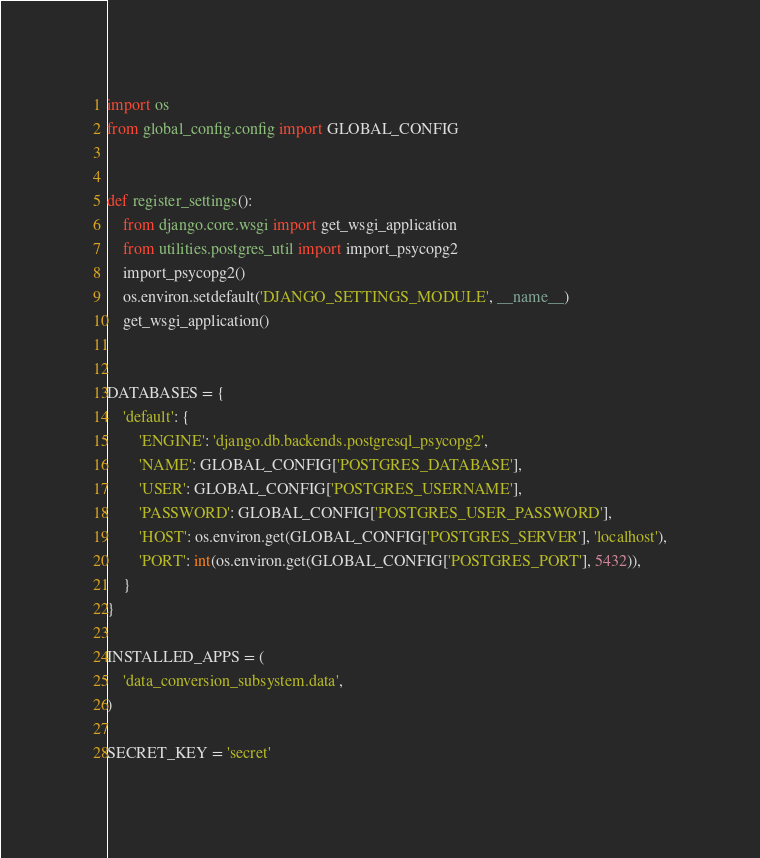<code> <loc_0><loc_0><loc_500><loc_500><_Python_>import os
from global_config.config import GLOBAL_CONFIG


def register_settings():
    from django.core.wsgi import get_wsgi_application
    from utilities.postgres_util import import_psycopg2
    import_psycopg2()
    os.environ.setdefault('DJANGO_SETTINGS_MODULE', __name__)
    get_wsgi_application()


DATABASES = {
    'default': {
        'ENGINE': 'django.db.backends.postgresql_psycopg2',
        'NAME': GLOBAL_CONFIG['POSTGRES_DATABASE'],
        'USER': GLOBAL_CONFIG['POSTGRES_USERNAME'],
        'PASSWORD': GLOBAL_CONFIG['POSTGRES_USER_PASSWORD'],
        'HOST': os.environ.get(GLOBAL_CONFIG['POSTGRES_SERVER'], 'localhost'),
        'PORT': int(os.environ.get(GLOBAL_CONFIG['POSTGRES_PORT'], 5432)),
    }
}

INSTALLED_APPS = (
    'data_conversion_subsystem.data',
)

SECRET_KEY = 'secret'
</code> 